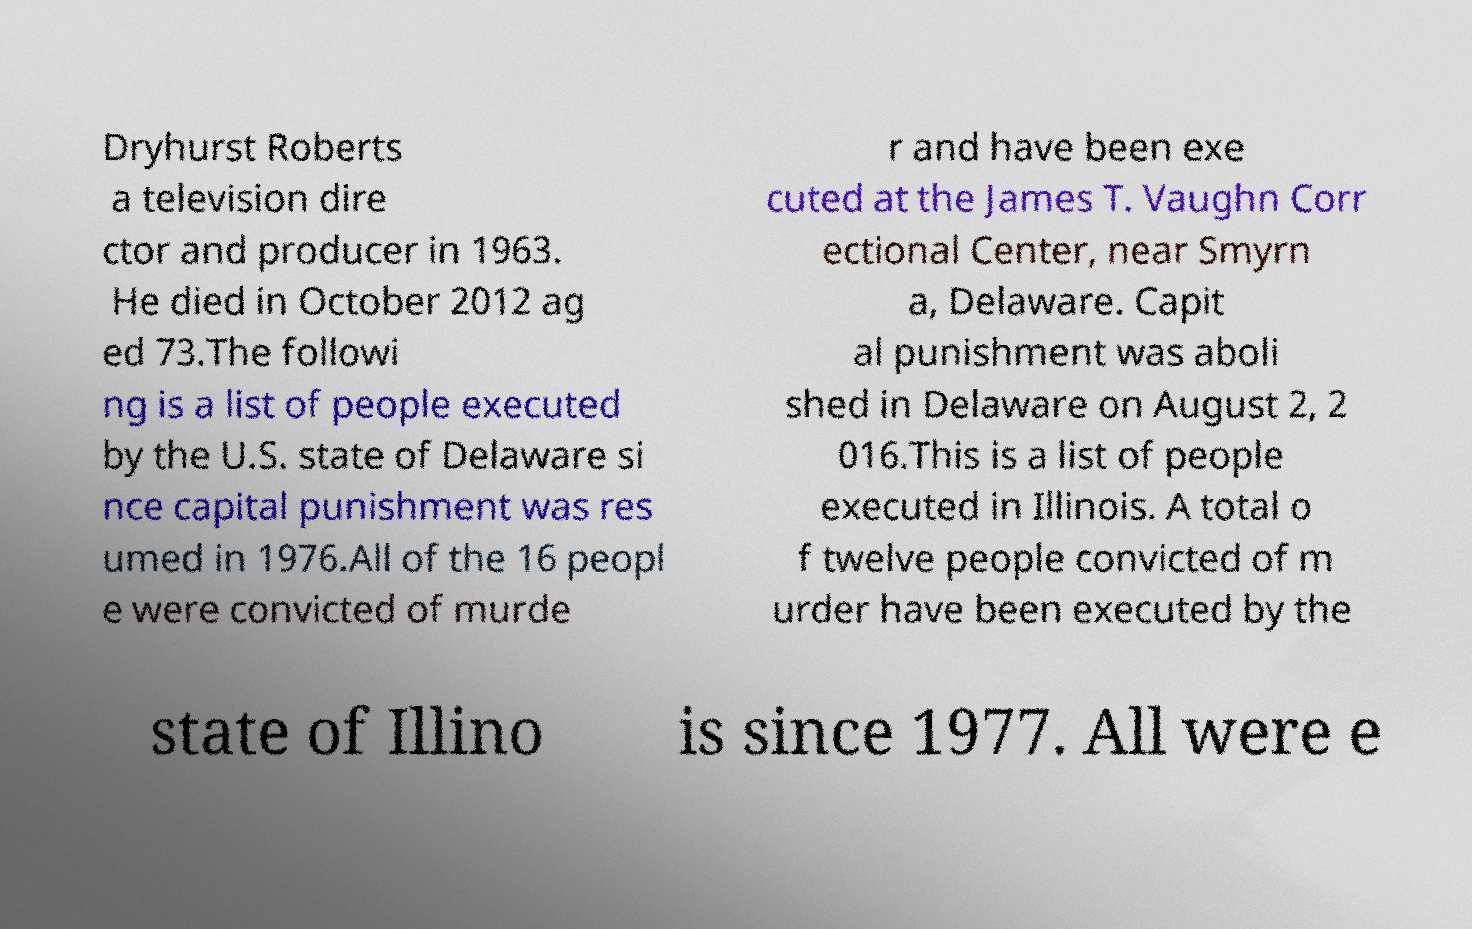There's text embedded in this image that I need extracted. Can you transcribe it verbatim? Dryhurst Roberts a television dire ctor and producer in 1963. He died in October 2012 ag ed 73.The followi ng is a list of people executed by the U.S. state of Delaware si nce capital punishment was res umed in 1976.All of the 16 peopl e were convicted of murde r and have been exe cuted at the James T. Vaughn Corr ectional Center, near Smyrn a, Delaware. Capit al punishment was aboli shed in Delaware on August 2, 2 016.This is a list of people executed in Illinois. A total o f twelve people convicted of m urder have been executed by the state of Illino is since 1977. All were e 